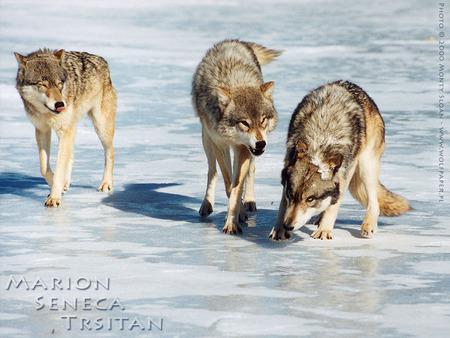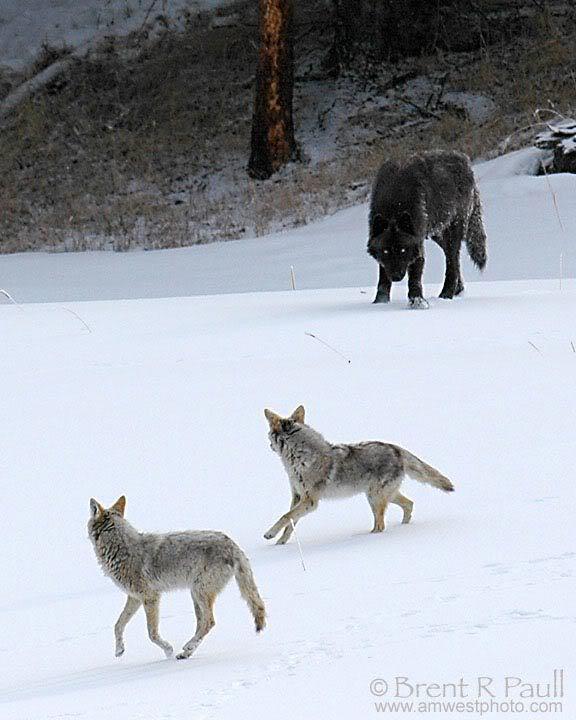The first image is the image on the left, the second image is the image on the right. Considering the images on both sides, is "A single wolf is pictured sleeping in one of the images." valid? Answer yes or no. No. 